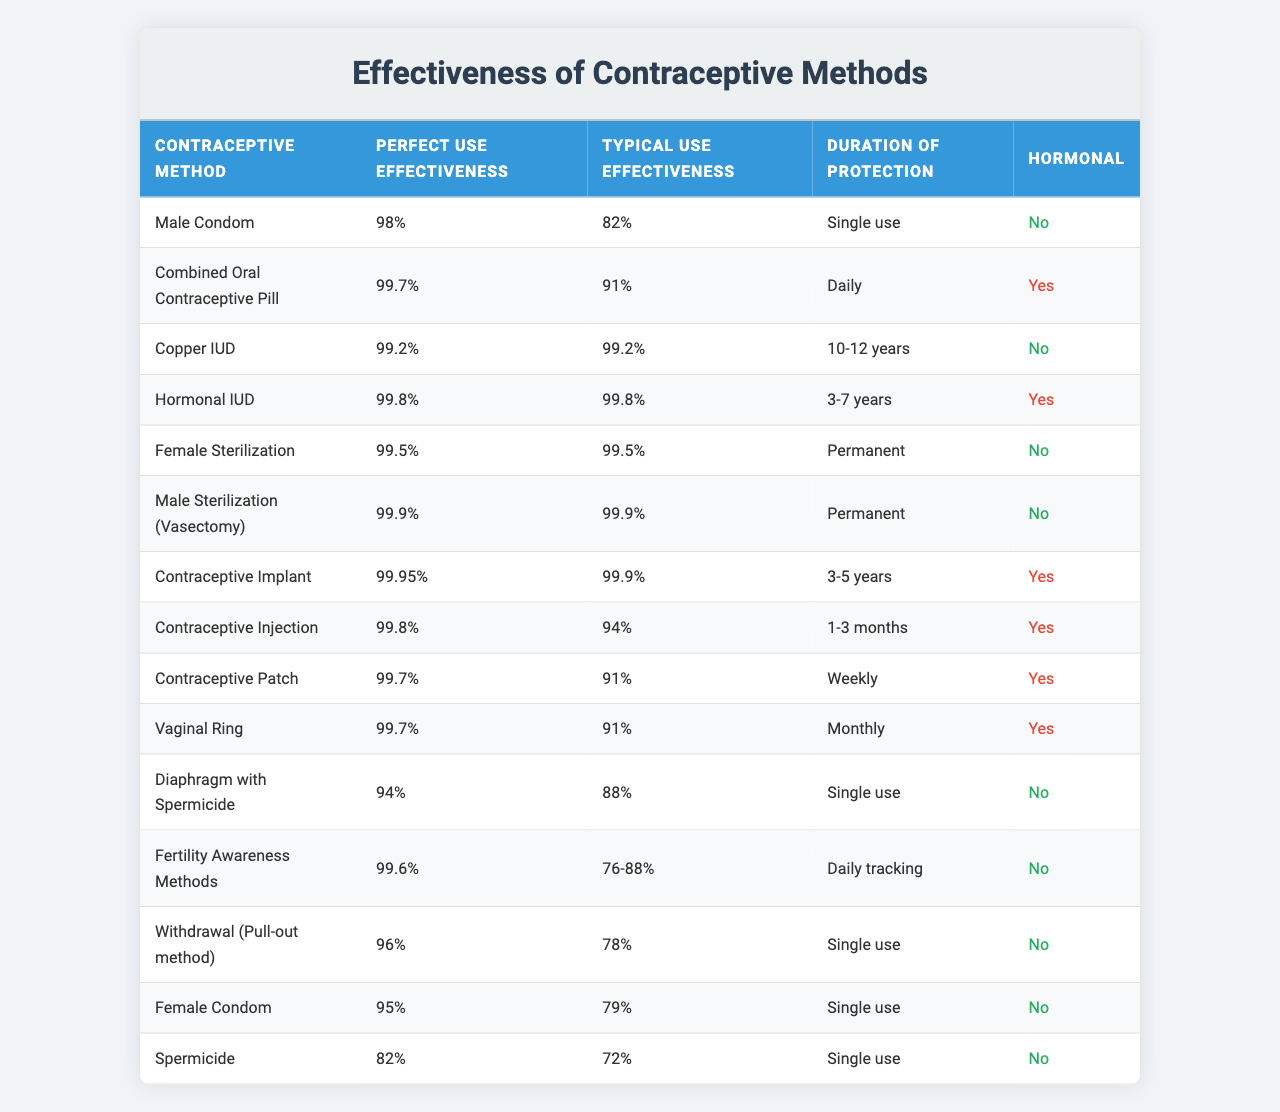What is the effectiveness rate of the Combined Oral Contraceptive Pill for perfect use? The table lists the effectiveness rate for the Combined Oral Contraceptive Pill under the "Perfect Use Effectiveness" column, which is 99.7%.
Answer: 99.7% Which contraceptive method has a typical use effectiveness of 72%? By searching the "Typical Use Effectiveness" column in the table, we find that the Spermicide has a typical use effectiveness of 72%.
Answer: Spermicide Is the Copper IUD a hormonal method? Referring to the "Hormonal" column, the Copper IUD is marked as "No", indicating it is not a hormonal method.
Answer: No What is the average typical use effectiveness of hormonal contraceptive methods? The hormonal methods listed are Combined Oral Contraceptive Pill (91%), Hormonal IUD (99.8%), Contraceptive Implant (99.9%), Contraceptive Injection (94%), Contraceptive Patch (91%), and Vaginal Ring (91%). Adding these values: (91 + 99.8 + 99.9 + 94 + 91 + 91) = 586. Dividing by the number of methods (6) gives an average of 586/6 = 97.67%.
Answer: 97.67% Which method provides permanent protection according to the table? Looking at the "Duration of Protection" column, we see that both Female Sterilization and Male Sterilization (Vasectomy) offer permanent protection.
Answer: Female Sterilization and Male Sterilization (Vasectomy) How does the effectiveness of Male Condoms for typical use compare to that of the Withdrawal method? The table states that Male Condoms have a typical use effectiveness of 82%, whereas the Withdrawal method has a typical use effectiveness of 78%. Male Condoms are more effective by a difference of 4%.
Answer: Male Condoms are more effective by 4% What is the difference in perfect use effectiveness between the Contraceptive Implant and the Diaphragm with Spermicide? The Contraceptive Implant has a perfect use effectiveness of 99.95%, while the Diaphragm with Spermicide has 94%. The difference is 99.95% - 94% = 5.95%.
Answer: 5.95% Which method has the longest duration of protection? The Copper IUD provides protection for 10-12 years, which is the longest duration mentioned in the table.
Answer: Copper IUD Is there any contraceptive method listed that has a 100% perfect use effectiveness? Reviewing the table, none of the contraceptive methods listed have a perfect use effectiveness of 100%; the highest is 99.9% for Male Sterilization (Vasectomy).
Answer: No Compare the typical use effectiveness of the Contraceptive Patch with the Contraceptive Injection. The Contraceptive Patch has a typical use effectiveness of 91%, while the Contraceptive Injection has 94%. The Injection is more effective by 3%.
Answer: Contraceptive Injection is more effective by 3% 